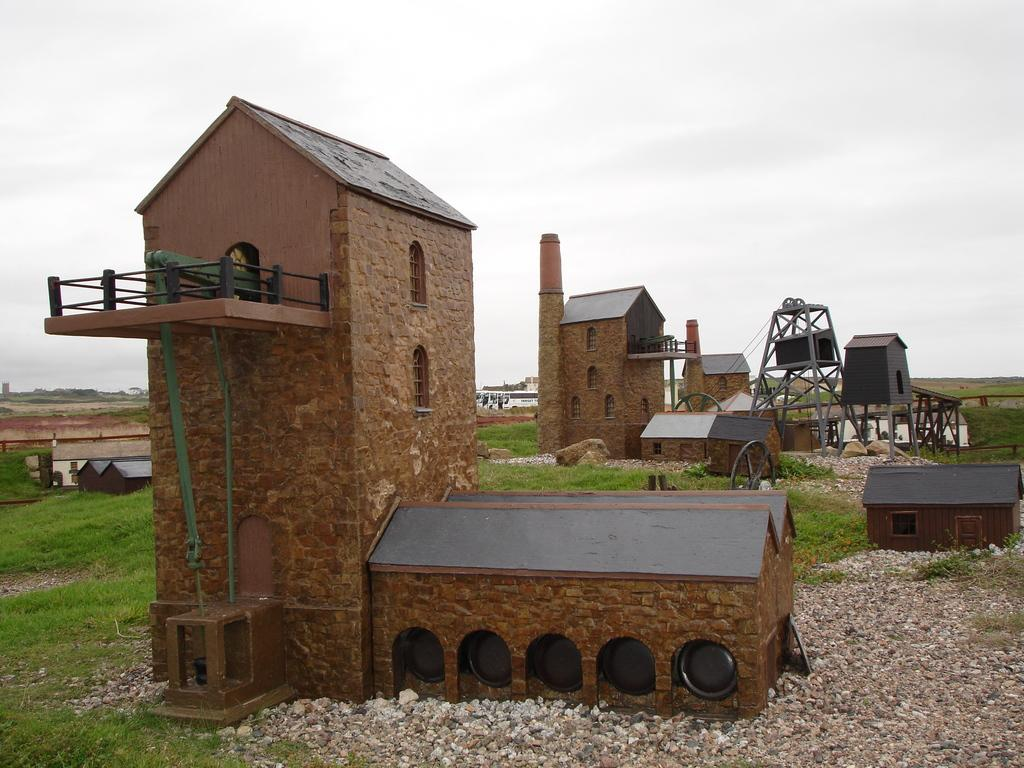What type of structures can be seen in the image? There are houses in the image. What else is present in the image besides the houses? There are objects and stones visible in the image. What type of vegetation is present in the image? There is grass in the image. What can be seen in the background of the image? The sky is visible in the background of the image. Can you describe the crime scene depicted in the image? There is no crime scene present in the image; it features houses, objects, stones, grass, and the sky. What type of furniture can be seen in the image? There is no furniture, such as a sofa, present in the image. 